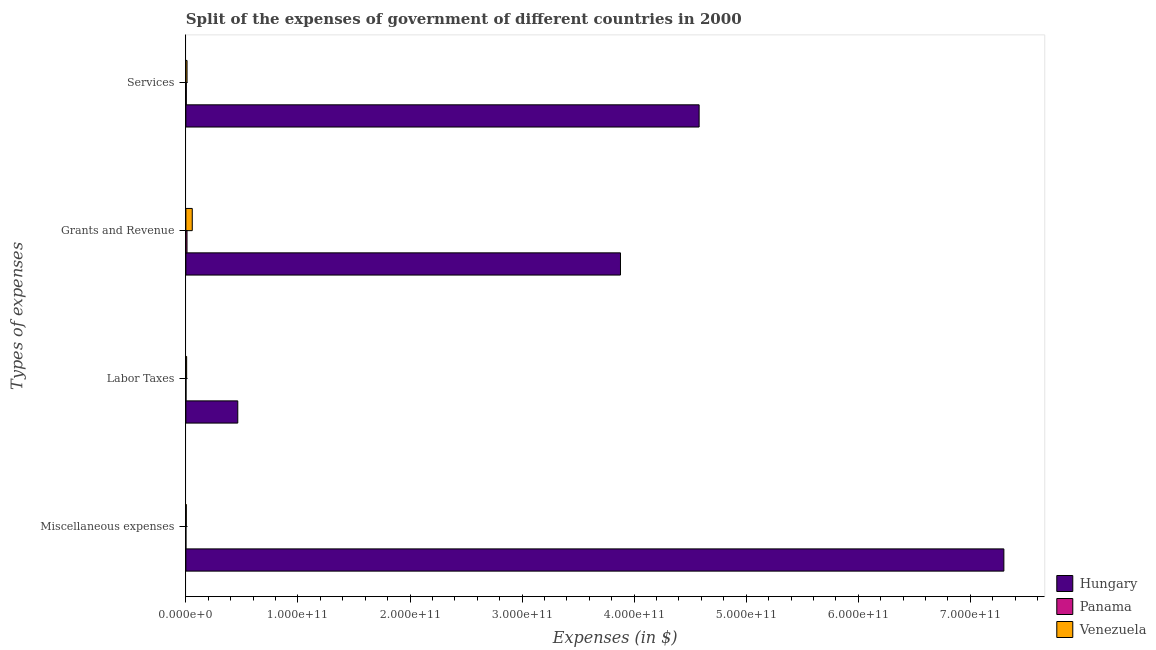How many bars are there on the 2nd tick from the top?
Give a very brief answer. 3. How many bars are there on the 4th tick from the bottom?
Offer a terse response. 3. What is the label of the 3rd group of bars from the top?
Give a very brief answer. Labor Taxes. What is the amount spent on labor taxes in Hungary?
Your response must be concise. 4.63e+1. Across all countries, what is the maximum amount spent on miscellaneous expenses?
Provide a short and direct response. 7.30e+11. Across all countries, what is the minimum amount spent on labor taxes?
Provide a short and direct response. 1.12e+08. In which country was the amount spent on services maximum?
Make the answer very short. Hungary. In which country was the amount spent on miscellaneous expenses minimum?
Your answer should be very brief. Panama. What is the total amount spent on services in the graph?
Your response must be concise. 4.59e+11. What is the difference between the amount spent on grants and revenue in Venezuela and that in Hungary?
Provide a short and direct response. -3.82e+11. What is the difference between the amount spent on services in Venezuela and the amount spent on grants and revenue in Hungary?
Provide a succinct answer. -3.87e+11. What is the average amount spent on labor taxes per country?
Offer a terse response. 1.57e+1. What is the difference between the amount spent on grants and revenue and amount spent on miscellaneous expenses in Venezuela?
Provide a short and direct response. 5.34e+09. In how many countries, is the amount spent on services greater than 640000000000 $?
Offer a very short reply. 0. What is the ratio of the amount spent on miscellaneous expenses in Venezuela to that in Panama?
Ensure brevity in your answer.  22.23. Is the amount spent on grants and revenue in Panama less than that in Hungary?
Ensure brevity in your answer.  Yes. What is the difference between the highest and the second highest amount spent on miscellaneous expenses?
Offer a very short reply. 7.30e+11. What is the difference between the highest and the lowest amount spent on labor taxes?
Your answer should be very brief. 4.62e+1. In how many countries, is the amount spent on services greater than the average amount spent on services taken over all countries?
Give a very brief answer. 1. What does the 1st bar from the top in Miscellaneous expenses represents?
Make the answer very short. Venezuela. What does the 3rd bar from the bottom in Labor Taxes represents?
Offer a very short reply. Venezuela. Is it the case that in every country, the sum of the amount spent on miscellaneous expenses and amount spent on labor taxes is greater than the amount spent on grants and revenue?
Ensure brevity in your answer.  No. What is the difference between two consecutive major ticks on the X-axis?
Your answer should be compact. 1.00e+11. Are the values on the major ticks of X-axis written in scientific E-notation?
Offer a very short reply. Yes. Does the graph contain grids?
Your answer should be compact. No. How many legend labels are there?
Offer a terse response. 3. What is the title of the graph?
Provide a short and direct response. Split of the expenses of government of different countries in 2000. Does "Sri Lanka" appear as one of the legend labels in the graph?
Your response must be concise. No. What is the label or title of the X-axis?
Your answer should be very brief. Expenses (in $). What is the label or title of the Y-axis?
Offer a terse response. Types of expenses. What is the Expenses (in $) in Hungary in Miscellaneous expenses?
Offer a very short reply. 7.30e+11. What is the Expenses (in $) in Panama in Miscellaneous expenses?
Your answer should be compact. 1.60e+07. What is the Expenses (in $) of Venezuela in Miscellaneous expenses?
Provide a short and direct response. 3.56e+08. What is the Expenses (in $) in Hungary in Labor Taxes?
Your response must be concise. 4.63e+1. What is the Expenses (in $) in Panama in Labor Taxes?
Your answer should be compact. 1.12e+08. What is the Expenses (in $) of Venezuela in Labor Taxes?
Ensure brevity in your answer.  6.78e+08. What is the Expenses (in $) in Hungary in Grants and Revenue?
Your answer should be compact. 3.88e+11. What is the Expenses (in $) in Panama in Grants and Revenue?
Give a very brief answer. 1.02e+09. What is the Expenses (in $) of Venezuela in Grants and Revenue?
Give a very brief answer. 5.70e+09. What is the Expenses (in $) in Hungary in Services?
Offer a terse response. 4.58e+11. What is the Expenses (in $) of Panama in Services?
Give a very brief answer. 3.88e+08. What is the Expenses (in $) in Venezuela in Services?
Give a very brief answer. 1.04e+09. Across all Types of expenses, what is the maximum Expenses (in $) in Hungary?
Your answer should be compact. 7.30e+11. Across all Types of expenses, what is the maximum Expenses (in $) in Panama?
Provide a short and direct response. 1.02e+09. Across all Types of expenses, what is the maximum Expenses (in $) in Venezuela?
Ensure brevity in your answer.  5.70e+09. Across all Types of expenses, what is the minimum Expenses (in $) in Hungary?
Provide a succinct answer. 4.63e+1. Across all Types of expenses, what is the minimum Expenses (in $) of Panama?
Offer a very short reply. 1.60e+07. Across all Types of expenses, what is the minimum Expenses (in $) of Venezuela?
Keep it short and to the point. 3.56e+08. What is the total Expenses (in $) in Hungary in the graph?
Your answer should be very brief. 1.62e+12. What is the total Expenses (in $) of Panama in the graph?
Keep it short and to the point. 1.54e+09. What is the total Expenses (in $) in Venezuela in the graph?
Provide a succinct answer. 7.77e+09. What is the difference between the Expenses (in $) of Hungary in Miscellaneous expenses and that in Labor Taxes?
Your answer should be very brief. 6.84e+11. What is the difference between the Expenses (in $) of Panama in Miscellaneous expenses and that in Labor Taxes?
Offer a terse response. -9.57e+07. What is the difference between the Expenses (in $) in Venezuela in Miscellaneous expenses and that in Labor Taxes?
Give a very brief answer. -3.22e+08. What is the difference between the Expenses (in $) of Hungary in Miscellaneous expenses and that in Grants and Revenue?
Make the answer very short. 3.42e+11. What is the difference between the Expenses (in $) in Panama in Miscellaneous expenses and that in Grants and Revenue?
Offer a very short reply. -1.01e+09. What is the difference between the Expenses (in $) of Venezuela in Miscellaneous expenses and that in Grants and Revenue?
Offer a terse response. -5.34e+09. What is the difference between the Expenses (in $) in Hungary in Miscellaneous expenses and that in Services?
Ensure brevity in your answer.  2.72e+11. What is the difference between the Expenses (in $) in Panama in Miscellaneous expenses and that in Services?
Keep it short and to the point. -3.72e+08. What is the difference between the Expenses (in $) in Venezuela in Miscellaneous expenses and that in Services?
Make the answer very short. -6.83e+08. What is the difference between the Expenses (in $) of Hungary in Labor Taxes and that in Grants and Revenue?
Make the answer very short. -3.42e+11. What is the difference between the Expenses (in $) of Panama in Labor Taxes and that in Grants and Revenue?
Ensure brevity in your answer.  -9.10e+08. What is the difference between the Expenses (in $) in Venezuela in Labor Taxes and that in Grants and Revenue?
Provide a short and direct response. -5.02e+09. What is the difference between the Expenses (in $) in Hungary in Labor Taxes and that in Services?
Ensure brevity in your answer.  -4.12e+11. What is the difference between the Expenses (in $) of Panama in Labor Taxes and that in Services?
Your answer should be very brief. -2.77e+08. What is the difference between the Expenses (in $) in Venezuela in Labor Taxes and that in Services?
Offer a very short reply. -3.61e+08. What is the difference between the Expenses (in $) of Hungary in Grants and Revenue and that in Services?
Ensure brevity in your answer.  -7.02e+1. What is the difference between the Expenses (in $) in Panama in Grants and Revenue and that in Services?
Give a very brief answer. 6.33e+08. What is the difference between the Expenses (in $) of Venezuela in Grants and Revenue and that in Services?
Offer a terse response. 4.66e+09. What is the difference between the Expenses (in $) in Hungary in Miscellaneous expenses and the Expenses (in $) in Panama in Labor Taxes?
Give a very brief answer. 7.30e+11. What is the difference between the Expenses (in $) in Hungary in Miscellaneous expenses and the Expenses (in $) in Venezuela in Labor Taxes?
Your response must be concise. 7.29e+11. What is the difference between the Expenses (in $) of Panama in Miscellaneous expenses and the Expenses (in $) of Venezuela in Labor Taxes?
Keep it short and to the point. -6.62e+08. What is the difference between the Expenses (in $) of Hungary in Miscellaneous expenses and the Expenses (in $) of Panama in Grants and Revenue?
Make the answer very short. 7.29e+11. What is the difference between the Expenses (in $) of Hungary in Miscellaneous expenses and the Expenses (in $) of Venezuela in Grants and Revenue?
Give a very brief answer. 7.24e+11. What is the difference between the Expenses (in $) in Panama in Miscellaneous expenses and the Expenses (in $) in Venezuela in Grants and Revenue?
Your response must be concise. -5.68e+09. What is the difference between the Expenses (in $) in Hungary in Miscellaneous expenses and the Expenses (in $) in Panama in Services?
Your answer should be compact. 7.30e+11. What is the difference between the Expenses (in $) in Hungary in Miscellaneous expenses and the Expenses (in $) in Venezuela in Services?
Your answer should be very brief. 7.29e+11. What is the difference between the Expenses (in $) of Panama in Miscellaneous expenses and the Expenses (in $) of Venezuela in Services?
Offer a terse response. -1.02e+09. What is the difference between the Expenses (in $) of Hungary in Labor Taxes and the Expenses (in $) of Panama in Grants and Revenue?
Make the answer very short. 4.53e+1. What is the difference between the Expenses (in $) of Hungary in Labor Taxes and the Expenses (in $) of Venezuela in Grants and Revenue?
Offer a terse response. 4.06e+1. What is the difference between the Expenses (in $) in Panama in Labor Taxes and the Expenses (in $) in Venezuela in Grants and Revenue?
Provide a short and direct response. -5.58e+09. What is the difference between the Expenses (in $) in Hungary in Labor Taxes and the Expenses (in $) in Panama in Services?
Your answer should be compact. 4.59e+1. What is the difference between the Expenses (in $) of Hungary in Labor Taxes and the Expenses (in $) of Venezuela in Services?
Provide a succinct answer. 4.53e+1. What is the difference between the Expenses (in $) in Panama in Labor Taxes and the Expenses (in $) in Venezuela in Services?
Make the answer very short. -9.27e+08. What is the difference between the Expenses (in $) of Hungary in Grants and Revenue and the Expenses (in $) of Panama in Services?
Ensure brevity in your answer.  3.87e+11. What is the difference between the Expenses (in $) of Hungary in Grants and Revenue and the Expenses (in $) of Venezuela in Services?
Keep it short and to the point. 3.87e+11. What is the difference between the Expenses (in $) in Panama in Grants and Revenue and the Expenses (in $) in Venezuela in Services?
Your answer should be very brief. -1.78e+07. What is the average Expenses (in $) of Hungary per Types of expenses?
Your answer should be very brief. 4.06e+11. What is the average Expenses (in $) of Panama per Types of expenses?
Offer a terse response. 3.84e+08. What is the average Expenses (in $) in Venezuela per Types of expenses?
Keep it short and to the point. 1.94e+09. What is the difference between the Expenses (in $) of Hungary and Expenses (in $) of Panama in Miscellaneous expenses?
Keep it short and to the point. 7.30e+11. What is the difference between the Expenses (in $) of Hungary and Expenses (in $) of Venezuela in Miscellaneous expenses?
Make the answer very short. 7.30e+11. What is the difference between the Expenses (in $) of Panama and Expenses (in $) of Venezuela in Miscellaneous expenses?
Offer a very short reply. -3.40e+08. What is the difference between the Expenses (in $) of Hungary and Expenses (in $) of Panama in Labor Taxes?
Your response must be concise. 4.62e+1. What is the difference between the Expenses (in $) of Hungary and Expenses (in $) of Venezuela in Labor Taxes?
Your response must be concise. 4.56e+1. What is the difference between the Expenses (in $) in Panama and Expenses (in $) in Venezuela in Labor Taxes?
Offer a terse response. -5.66e+08. What is the difference between the Expenses (in $) in Hungary and Expenses (in $) in Panama in Grants and Revenue?
Your response must be concise. 3.87e+11. What is the difference between the Expenses (in $) of Hungary and Expenses (in $) of Venezuela in Grants and Revenue?
Offer a terse response. 3.82e+11. What is the difference between the Expenses (in $) in Panama and Expenses (in $) in Venezuela in Grants and Revenue?
Offer a terse response. -4.67e+09. What is the difference between the Expenses (in $) in Hungary and Expenses (in $) in Panama in Services?
Provide a succinct answer. 4.58e+11. What is the difference between the Expenses (in $) of Hungary and Expenses (in $) of Venezuela in Services?
Ensure brevity in your answer.  4.57e+11. What is the difference between the Expenses (in $) of Panama and Expenses (in $) of Venezuela in Services?
Offer a terse response. -6.51e+08. What is the ratio of the Expenses (in $) of Hungary in Miscellaneous expenses to that in Labor Taxes?
Offer a terse response. 15.76. What is the ratio of the Expenses (in $) in Panama in Miscellaneous expenses to that in Labor Taxes?
Give a very brief answer. 0.14. What is the ratio of the Expenses (in $) of Venezuela in Miscellaneous expenses to that in Labor Taxes?
Ensure brevity in your answer.  0.52. What is the ratio of the Expenses (in $) of Hungary in Miscellaneous expenses to that in Grants and Revenue?
Your response must be concise. 1.88. What is the ratio of the Expenses (in $) in Panama in Miscellaneous expenses to that in Grants and Revenue?
Ensure brevity in your answer.  0.02. What is the ratio of the Expenses (in $) in Venezuela in Miscellaneous expenses to that in Grants and Revenue?
Your answer should be compact. 0.06. What is the ratio of the Expenses (in $) in Hungary in Miscellaneous expenses to that in Services?
Your response must be concise. 1.59. What is the ratio of the Expenses (in $) in Panama in Miscellaneous expenses to that in Services?
Ensure brevity in your answer.  0.04. What is the ratio of the Expenses (in $) in Venezuela in Miscellaneous expenses to that in Services?
Your answer should be compact. 0.34. What is the ratio of the Expenses (in $) in Hungary in Labor Taxes to that in Grants and Revenue?
Your response must be concise. 0.12. What is the ratio of the Expenses (in $) in Panama in Labor Taxes to that in Grants and Revenue?
Your answer should be very brief. 0.11. What is the ratio of the Expenses (in $) in Venezuela in Labor Taxes to that in Grants and Revenue?
Keep it short and to the point. 0.12. What is the ratio of the Expenses (in $) in Hungary in Labor Taxes to that in Services?
Provide a short and direct response. 0.1. What is the ratio of the Expenses (in $) of Panama in Labor Taxes to that in Services?
Your answer should be very brief. 0.29. What is the ratio of the Expenses (in $) in Venezuela in Labor Taxes to that in Services?
Make the answer very short. 0.65. What is the ratio of the Expenses (in $) of Hungary in Grants and Revenue to that in Services?
Offer a very short reply. 0.85. What is the ratio of the Expenses (in $) of Panama in Grants and Revenue to that in Services?
Provide a succinct answer. 2.63. What is the ratio of the Expenses (in $) of Venezuela in Grants and Revenue to that in Services?
Provide a short and direct response. 5.48. What is the difference between the highest and the second highest Expenses (in $) in Hungary?
Your answer should be compact. 2.72e+11. What is the difference between the highest and the second highest Expenses (in $) of Panama?
Ensure brevity in your answer.  6.33e+08. What is the difference between the highest and the second highest Expenses (in $) in Venezuela?
Your answer should be very brief. 4.66e+09. What is the difference between the highest and the lowest Expenses (in $) of Hungary?
Offer a terse response. 6.84e+11. What is the difference between the highest and the lowest Expenses (in $) in Panama?
Offer a terse response. 1.01e+09. What is the difference between the highest and the lowest Expenses (in $) in Venezuela?
Provide a succinct answer. 5.34e+09. 